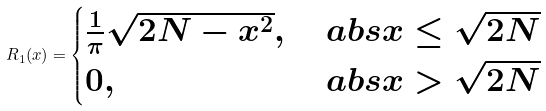Convert formula to latex. <formula><loc_0><loc_0><loc_500><loc_500>R _ { 1 } ( x ) = \begin{cases} \frac { 1 } { \pi } \sqrt { 2 N - x ^ { 2 } } , & \ a b s { x } \leq \sqrt { 2 N } \\ 0 , & \ a b s { x } > \sqrt { 2 N } \end{cases}</formula> 